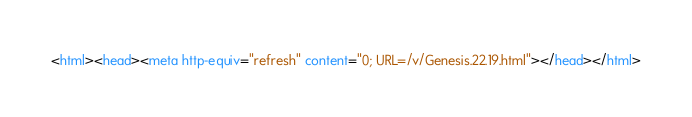<code> <loc_0><loc_0><loc_500><loc_500><_HTML_><html><head><meta http-equiv="refresh" content="0; URL=/v/Genesis.22.19.html"></head></html></code> 